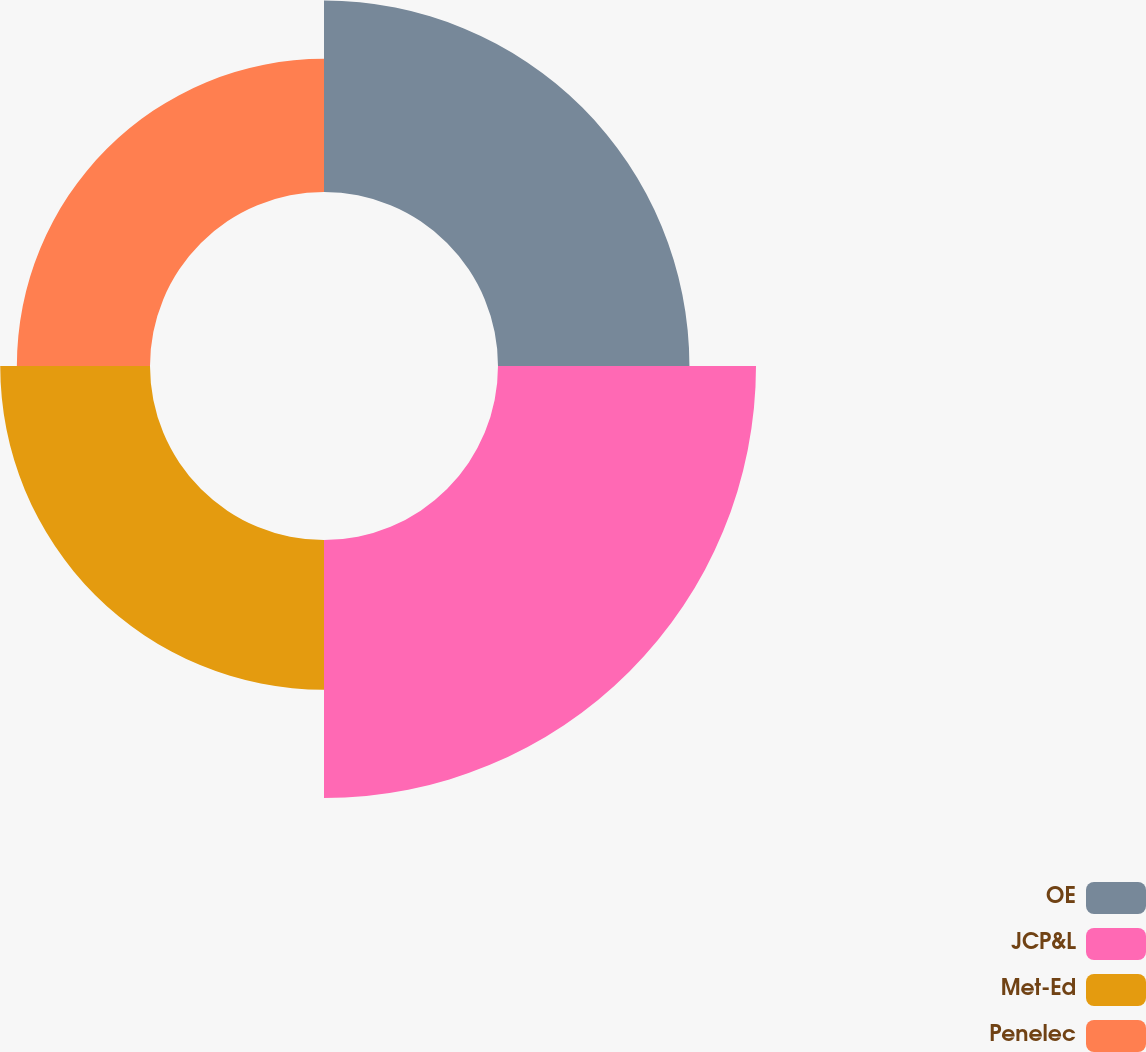<chart> <loc_0><loc_0><loc_500><loc_500><pie_chart><fcel>OE<fcel>JCP&L<fcel>Met-Ed<fcel>Penelec<nl><fcel>26.14%<fcel>35.23%<fcel>20.45%<fcel>18.18%<nl></chart> 